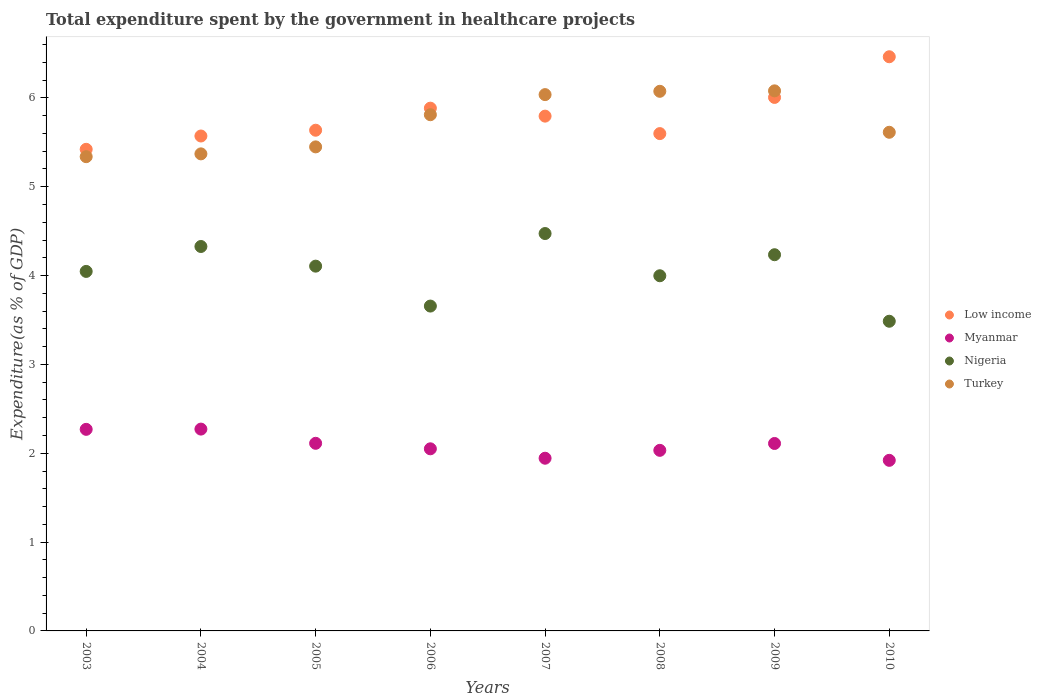Is the number of dotlines equal to the number of legend labels?
Offer a terse response. Yes. What is the total expenditure spent by the government in healthcare projects in Low income in 2006?
Give a very brief answer. 5.88. Across all years, what is the maximum total expenditure spent by the government in healthcare projects in Myanmar?
Give a very brief answer. 2.27. Across all years, what is the minimum total expenditure spent by the government in healthcare projects in Myanmar?
Keep it short and to the point. 1.92. What is the total total expenditure spent by the government in healthcare projects in Low income in the graph?
Your response must be concise. 46.38. What is the difference between the total expenditure spent by the government in healthcare projects in Nigeria in 2004 and that in 2008?
Offer a terse response. 0.33. What is the difference between the total expenditure spent by the government in healthcare projects in Turkey in 2004 and the total expenditure spent by the government in healthcare projects in Myanmar in 2008?
Your response must be concise. 3.34. What is the average total expenditure spent by the government in healthcare projects in Nigeria per year?
Provide a short and direct response. 4.04. In the year 2005, what is the difference between the total expenditure spent by the government in healthcare projects in Low income and total expenditure spent by the government in healthcare projects in Turkey?
Give a very brief answer. 0.19. What is the ratio of the total expenditure spent by the government in healthcare projects in Myanmar in 2004 to that in 2006?
Provide a short and direct response. 1.11. What is the difference between the highest and the second highest total expenditure spent by the government in healthcare projects in Nigeria?
Provide a succinct answer. 0.15. What is the difference between the highest and the lowest total expenditure spent by the government in healthcare projects in Turkey?
Provide a succinct answer. 0.74. In how many years, is the total expenditure spent by the government in healthcare projects in Turkey greater than the average total expenditure spent by the government in healthcare projects in Turkey taken over all years?
Keep it short and to the point. 4. Is it the case that in every year, the sum of the total expenditure spent by the government in healthcare projects in Turkey and total expenditure spent by the government in healthcare projects in Low income  is greater than the total expenditure spent by the government in healthcare projects in Nigeria?
Keep it short and to the point. Yes. Is the total expenditure spent by the government in healthcare projects in Turkey strictly greater than the total expenditure spent by the government in healthcare projects in Myanmar over the years?
Your answer should be compact. Yes. How many dotlines are there?
Provide a short and direct response. 4. What is the difference between two consecutive major ticks on the Y-axis?
Your response must be concise. 1. Does the graph contain any zero values?
Make the answer very short. No. Does the graph contain grids?
Ensure brevity in your answer.  No. How many legend labels are there?
Provide a succinct answer. 4. What is the title of the graph?
Keep it short and to the point. Total expenditure spent by the government in healthcare projects. Does "Kosovo" appear as one of the legend labels in the graph?
Ensure brevity in your answer.  No. What is the label or title of the X-axis?
Your response must be concise. Years. What is the label or title of the Y-axis?
Keep it short and to the point. Expenditure(as % of GDP). What is the Expenditure(as % of GDP) in Low income in 2003?
Your answer should be compact. 5.42. What is the Expenditure(as % of GDP) in Myanmar in 2003?
Make the answer very short. 2.27. What is the Expenditure(as % of GDP) of Nigeria in 2003?
Your response must be concise. 4.05. What is the Expenditure(as % of GDP) of Turkey in 2003?
Your answer should be very brief. 5.34. What is the Expenditure(as % of GDP) of Low income in 2004?
Your answer should be very brief. 5.57. What is the Expenditure(as % of GDP) in Myanmar in 2004?
Provide a succinct answer. 2.27. What is the Expenditure(as % of GDP) of Nigeria in 2004?
Offer a very short reply. 4.33. What is the Expenditure(as % of GDP) of Turkey in 2004?
Provide a short and direct response. 5.37. What is the Expenditure(as % of GDP) in Low income in 2005?
Give a very brief answer. 5.64. What is the Expenditure(as % of GDP) in Myanmar in 2005?
Your response must be concise. 2.11. What is the Expenditure(as % of GDP) of Nigeria in 2005?
Your answer should be very brief. 4.11. What is the Expenditure(as % of GDP) of Turkey in 2005?
Offer a very short reply. 5.45. What is the Expenditure(as % of GDP) in Low income in 2006?
Your answer should be very brief. 5.88. What is the Expenditure(as % of GDP) of Myanmar in 2006?
Provide a short and direct response. 2.05. What is the Expenditure(as % of GDP) of Nigeria in 2006?
Keep it short and to the point. 3.66. What is the Expenditure(as % of GDP) of Turkey in 2006?
Offer a terse response. 5.81. What is the Expenditure(as % of GDP) of Low income in 2007?
Give a very brief answer. 5.8. What is the Expenditure(as % of GDP) of Myanmar in 2007?
Provide a succinct answer. 1.94. What is the Expenditure(as % of GDP) of Nigeria in 2007?
Your answer should be compact. 4.47. What is the Expenditure(as % of GDP) of Turkey in 2007?
Offer a terse response. 6.04. What is the Expenditure(as % of GDP) of Low income in 2008?
Your answer should be compact. 5.6. What is the Expenditure(as % of GDP) of Myanmar in 2008?
Your response must be concise. 2.03. What is the Expenditure(as % of GDP) in Nigeria in 2008?
Make the answer very short. 4. What is the Expenditure(as % of GDP) of Turkey in 2008?
Make the answer very short. 6.07. What is the Expenditure(as % of GDP) in Low income in 2009?
Provide a short and direct response. 6.01. What is the Expenditure(as % of GDP) in Myanmar in 2009?
Give a very brief answer. 2.11. What is the Expenditure(as % of GDP) in Nigeria in 2009?
Provide a short and direct response. 4.23. What is the Expenditure(as % of GDP) of Turkey in 2009?
Offer a terse response. 6.08. What is the Expenditure(as % of GDP) of Low income in 2010?
Keep it short and to the point. 6.46. What is the Expenditure(as % of GDP) in Myanmar in 2010?
Your response must be concise. 1.92. What is the Expenditure(as % of GDP) in Nigeria in 2010?
Make the answer very short. 3.49. What is the Expenditure(as % of GDP) in Turkey in 2010?
Ensure brevity in your answer.  5.61. Across all years, what is the maximum Expenditure(as % of GDP) in Low income?
Give a very brief answer. 6.46. Across all years, what is the maximum Expenditure(as % of GDP) of Myanmar?
Offer a terse response. 2.27. Across all years, what is the maximum Expenditure(as % of GDP) in Nigeria?
Your answer should be compact. 4.47. Across all years, what is the maximum Expenditure(as % of GDP) of Turkey?
Your answer should be very brief. 6.08. Across all years, what is the minimum Expenditure(as % of GDP) of Low income?
Provide a short and direct response. 5.42. Across all years, what is the minimum Expenditure(as % of GDP) of Myanmar?
Keep it short and to the point. 1.92. Across all years, what is the minimum Expenditure(as % of GDP) of Nigeria?
Your answer should be very brief. 3.49. Across all years, what is the minimum Expenditure(as % of GDP) of Turkey?
Offer a very short reply. 5.34. What is the total Expenditure(as % of GDP) in Low income in the graph?
Make the answer very short. 46.38. What is the total Expenditure(as % of GDP) of Myanmar in the graph?
Ensure brevity in your answer.  16.71. What is the total Expenditure(as % of GDP) in Nigeria in the graph?
Your response must be concise. 32.33. What is the total Expenditure(as % of GDP) in Turkey in the graph?
Provide a succinct answer. 45.77. What is the difference between the Expenditure(as % of GDP) of Low income in 2003 and that in 2004?
Offer a very short reply. -0.15. What is the difference between the Expenditure(as % of GDP) of Myanmar in 2003 and that in 2004?
Give a very brief answer. -0. What is the difference between the Expenditure(as % of GDP) of Nigeria in 2003 and that in 2004?
Give a very brief answer. -0.28. What is the difference between the Expenditure(as % of GDP) in Turkey in 2003 and that in 2004?
Keep it short and to the point. -0.03. What is the difference between the Expenditure(as % of GDP) in Low income in 2003 and that in 2005?
Offer a very short reply. -0.21. What is the difference between the Expenditure(as % of GDP) of Myanmar in 2003 and that in 2005?
Provide a short and direct response. 0.16. What is the difference between the Expenditure(as % of GDP) in Nigeria in 2003 and that in 2005?
Your answer should be very brief. -0.06. What is the difference between the Expenditure(as % of GDP) of Turkey in 2003 and that in 2005?
Keep it short and to the point. -0.11. What is the difference between the Expenditure(as % of GDP) of Low income in 2003 and that in 2006?
Keep it short and to the point. -0.46. What is the difference between the Expenditure(as % of GDP) of Myanmar in 2003 and that in 2006?
Give a very brief answer. 0.22. What is the difference between the Expenditure(as % of GDP) of Nigeria in 2003 and that in 2006?
Your answer should be very brief. 0.39. What is the difference between the Expenditure(as % of GDP) of Turkey in 2003 and that in 2006?
Make the answer very short. -0.47. What is the difference between the Expenditure(as % of GDP) of Low income in 2003 and that in 2007?
Your answer should be very brief. -0.37. What is the difference between the Expenditure(as % of GDP) of Myanmar in 2003 and that in 2007?
Your answer should be very brief. 0.33. What is the difference between the Expenditure(as % of GDP) in Nigeria in 2003 and that in 2007?
Give a very brief answer. -0.43. What is the difference between the Expenditure(as % of GDP) of Turkey in 2003 and that in 2007?
Your answer should be compact. -0.7. What is the difference between the Expenditure(as % of GDP) in Low income in 2003 and that in 2008?
Ensure brevity in your answer.  -0.18. What is the difference between the Expenditure(as % of GDP) in Myanmar in 2003 and that in 2008?
Your answer should be very brief. 0.24. What is the difference between the Expenditure(as % of GDP) in Nigeria in 2003 and that in 2008?
Offer a very short reply. 0.05. What is the difference between the Expenditure(as % of GDP) of Turkey in 2003 and that in 2008?
Your response must be concise. -0.74. What is the difference between the Expenditure(as % of GDP) in Low income in 2003 and that in 2009?
Your response must be concise. -0.58. What is the difference between the Expenditure(as % of GDP) in Myanmar in 2003 and that in 2009?
Ensure brevity in your answer.  0.16. What is the difference between the Expenditure(as % of GDP) of Nigeria in 2003 and that in 2009?
Give a very brief answer. -0.19. What is the difference between the Expenditure(as % of GDP) of Turkey in 2003 and that in 2009?
Ensure brevity in your answer.  -0.74. What is the difference between the Expenditure(as % of GDP) in Low income in 2003 and that in 2010?
Give a very brief answer. -1.04. What is the difference between the Expenditure(as % of GDP) of Myanmar in 2003 and that in 2010?
Your answer should be compact. 0.35. What is the difference between the Expenditure(as % of GDP) of Nigeria in 2003 and that in 2010?
Offer a very short reply. 0.56. What is the difference between the Expenditure(as % of GDP) of Turkey in 2003 and that in 2010?
Your response must be concise. -0.27. What is the difference between the Expenditure(as % of GDP) in Low income in 2004 and that in 2005?
Offer a terse response. -0.07. What is the difference between the Expenditure(as % of GDP) of Myanmar in 2004 and that in 2005?
Ensure brevity in your answer.  0.16. What is the difference between the Expenditure(as % of GDP) in Nigeria in 2004 and that in 2005?
Keep it short and to the point. 0.22. What is the difference between the Expenditure(as % of GDP) of Turkey in 2004 and that in 2005?
Your response must be concise. -0.08. What is the difference between the Expenditure(as % of GDP) in Low income in 2004 and that in 2006?
Offer a terse response. -0.31. What is the difference between the Expenditure(as % of GDP) of Myanmar in 2004 and that in 2006?
Your answer should be very brief. 0.22. What is the difference between the Expenditure(as % of GDP) in Nigeria in 2004 and that in 2006?
Your response must be concise. 0.67. What is the difference between the Expenditure(as % of GDP) in Turkey in 2004 and that in 2006?
Keep it short and to the point. -0.44. What is the difference between the Expenditure(as % of GDP) of Low income in 2004 and that in 2007?
Your response must be concise. -0.22. What is the difference between the Expenditure(as % of GDP) in Myanmar in 2004 and that in 2007?
Ensure brevity in your answer.  0.33. What is the difference between the Expenditure(as % of GDP) of Nigeria in 2004 and that in 2007?
Keep it short and to the point. -0.15. What is the difference between the Expenditure(as % of GDP) in Turkey in 2004 and that in 2007?
Offer a very short reply. -0.67. What is the difference between the Expenditure(as % of GDP) of Low income in 2004 and that in 2008?
Provide a short and direct response. -0.03. What is the difference between the Expenditure(as % of GDP) of Myanmar in 2004 and that in 2008?
Your answer should be very brief. 0.24. What is the difference between the Expenditure(as % of GDP) in Nigeria in 2004 and that in 2008?
Your answer should be very brief. 0.33. What is the difference between the Expenditure(as % of GDP) of Turkey in 2004 and that in 2008?
Your answer should be compact. -0.7. What is the difference between the Expenditure(as % of GDP) in Low income in 2004 and that in 2009?
Provide a short and direct response. -0.43. What is the difference between the Expenditure(as % of GDP) of Myanmar in 2004 and that in 2009?
Offer a terse response. 0.16. What is the difference between the Expenditure(as % of GDP) of Nigeria in 2004 and that in 2009?
Your response must be concise. 0.09. What is the difference between the Expenditure(as % of GDP) in Turkey in 2004 and that in 2009?
Keep it short and to the point. -0.71. What is the difference between the Expenditure(as % of GDP) in Low income in 2004 and that in 2010?
Provide a short and direct response. -0.89. What is the difference between the Expenditure(as % of GDP) of Myanmar in 2004 and that in 2010?
Your answer should be compact. 0.35. What is the difference between the Expenditure(as % of GDP) of Nigeria in 2004 and that in 2010?
Your answer should be compact. 0.84. What is the difference between the Expenditure(as % of GDP) of Turkey in 2004 and that in 2010?
Offer a very short reply. -0.24. What is the difference between the Expenditure(as % of GDP) in Low income in 2005 and that in 2006?
Offer a very short reply. -0.25. What is the difference between the Expenditure(as % of GDP) of Myanmar in 2005 and that in 2006?
Your answer should be compact. 0.06. What is the difference between the Expenditure(as % of GDP) of Nigeria in 2005 and that in 2006?
Provide a succinct answer. 0.45. What is the difference between the Expenditure(as % of GDP) in Turkey in 2005 and that in 2006?
Give a very brief answer. -0.36. What is the difference between the Expenditure(as % of GDP) in Low income in 2005 and that in 2007?
Provide a short and direct response. -0.16. What is the difference between the Expenditure(as % of GDP) of Myanmar in 2005 and that in 2007?
Make the answer very short. 0.17. What is the difference between the Expenditure(as % of GDP) in Nigeria in 2005 and that in 2007?
Your answer should be compact. -0.37. What is the difference between the Expenditure(as % of GDP) in Turkey in 2005 and that in 2007?
Give a very brief answer. -0.59. What is the difference between the Expenditure(as % of GDP) in Low income in 2005 and that in 2008?
Make the answer very short. 0.04. What is the difference between the Expenditure(as % of GDP) of Myanmar in 2005 and that in 2008?
Your response must be concise. 0.08. What is the difference between the Expenditure(as % of GDP) in Nigeria in 2005 and that in 2008?
Ensure brevity in your answer.  0.11. What is the difference between the Expenditure(as % of GDP) in Turkey in 2005 and that in 2008?
Offer a very short reply. -0.63. What is the difference between the Expenditure(as % of GDP) in Low income in 2005 and that in 2009?
Your answer should be compact. -0.37. What is the difference between the Expenditure(as % of GDP) in Myanmar in 2005 and that in 2009?
Your answer should be compact. 0. What is the difference between the Expenditure(as % of GDP) of Nigeria in 2005 and that in 2009?
Ensure brevity in your answer.  -0.13. What is the difference between the Expenditure(as % of GDP) of Turkey in 2005 and that in 2009?
Ensure brevity in your answer.  -0.63. What is the difference between the Expenditure(as % of GDP) in Low income in 2005 and that in 2010?
Your answer should be compact. -0.83. What is the difference between the Expenditure(as % of GDP) in Myanmar in 2005 and that in 2010?
Give a very brief answer. 0.19. What is the difference between the Expenditure(as % of GDP) of Nigeria in 2005 and that in 2010?
Provide a short and direct response. 0.62. What is the difference between the Expenditure(as % of GDP) of Turkey in 2005 and that in 2010?
Give a very brief answer. -0.16. What is the difference between the Expenditure(as % of GDP) in Low income in 2006 and that in 2007?
Ensure brevity in your answer.  0.09. What is the difference between the Expenditure(as % of GDP) of Myanmar in 2006 and that in 2007?
Keep it short and to the point. 0.11. What is the difference between the Expenditure(as % of GDP) in Nigeria in 2006 and that in 2007?
Offer a terse response. -0.82. What is the difference between the Expenditure(as % of GDP) of Turkey in 2006 and that in 2007?
Make the answer very short. -0.23. What is the difference between the Expenditure(as % of GDP) of Low income in 2006 and that in 2008?
Give a very brief answer. 0.29. What is the difference between the Expenditure(as % of GDP) in Myanmar in 2006 and that in 2008?
Offer a terse response. 0.02. What is the difference between the Expenditure(as % of GDP) in Nigeria in 2006 and that in 2008?
Offer a very short reply. -0.34. What is the difference between the Expenditure(as % of GDP) in Turkey in 2006 and that in 2008?
Provide a succinct answer. -0.26. What is the difference between the Expenditure(as % of GDP) in Low income in 2006 and that in 2009?
Your answer should be very brief. -0.12. What is the difference between the Expenditure(as % of GDP) of Myanmar in 2006 and that in 2009?
Give a very brief answer. -0.06. What is the difference between the Expenditure(as % of GDP) of Nigeria in 2006 and that in 2009?
Keep it short and to the point. -0.58. What is the difference between the Expenditure(as % of GDP) of Turkey in 2006 and that in 2009?
Offer a very short reply. -0.27. What is the difference between the Expenditure(as % of GDP) of Low income in 2006 and that in 2010?
Give a very brief answer. -0.58. What is the difference between the Expenditure(as % of GDP) of Myanmar in 2006 and that in 2010?
Ensure brevity in your answer.  0.13. What is the difference between the Expenditure(as % of GDP) in Nigeria in 2006 and that in 2010?
Your answer should be compact. 0.17. What is the difference between the Expenditure(as % of GDP) in Turkey in 2006 and that in 2010?
Give a very brief answer. 0.2. What is the difference between the Expenditure(as % of GDP) in Low income in 2007 and that in 2008?
Your response must be concise. 0.2. What is the difference between the Expenditure(as % of GDP) in Myanmar in 2007 and that in 2008?
Your answer should be very brief. -0.09. What is the difference between the Expenditure(as % of GDP) in Nigeria in 2007 and that in 2008?
Your answer should be compact. 0.48. What is the difference between the Expenditure(as % of GDP) in Turkey in 2007 and that in 2008?
Keep it short and to the point. -0.04. What is the difference between the Expenditure(as % of GDP) in Low income in 2007 and that in 2009?
Give a very brief answer. -0.21. What is the difference between the Expenditure(as % of GDP) of Myanmar in 2007 and that in 2009?
Offer a very short reply. -0.17. What is the difference between the Expenditure(as % of GDP) of Nigeria in 2007 and that in 2009?
Your response must be concise. 0.24. What is the difference between the Expenditure(as % of GDP) of Turkey in 2007 and that in 2009?
Keep it short and to the point. -0.04. What is the difference between the Expenditure(as % of GDP) of Low income in 2007 and that in 2010?
Provide a succinct answer. -0.67. What is the difference between the Expenditure(as % of GDP) in Myanmar in 2007 and that in 2010?
Make the answer very short. 0.02. What is the difference between the Expenditure(as % of GDP) of Nigeria in 2007 and that in 2010?
Give a very brief answer. 0.99. What is the difference between the Expenditure(as % of GDP) of Turkey in 2007 and that in 2010?
Your answer should be compact. 0.42. What is the difference between the Expenditure(as % of GDP) of Low income in 2008 and that in 2009?
Make the answer very short. -0.41. What is the difference between the Expenditure(as % of GDP) in Myanmar in 2008 and that in 2009?
Provide a short and direct response. -0.08. What is the difference between the Expenditure(as % of GDP) in Nigeria in 2008 and that in 2009?
Make the answer very short. -0.24. What is the difference between the Expenditure(as % of GDP) in Turkey in 2008 and that in 2009?
Make the answer very short. -0.01. What is the difference between the Expenditure(as % of GDP) of Low income in 2008 and that in 2010?
Make the answer very short. -0.87. What is the difference between the Expenditure(as % of GDP) of Myanmar in 2008 and that in 2010?
Your answer should be very brief. 0.11. What is the difference between the Expenditure(as % of GDP) of Nigeria in 2008 and that in 2010?
Give a very brief answer. 0.51. What is the difference between the Expenditure(as % of GDP) in Turkey in 2008 and that in 2010?
Your answer should be compact. 0.46. What is the difference between the Expenditure(as % of GDP) in Low income in 2009 and that in 2010?
Provide a short and direct response. -0.46. What is the difference between the Expenditure(as % of GDP) of Myanmar in 2009 and that in 2010?
Your response must be concise. 0.19. What is the difference between the Expenditure(as % of GDP) in Nigeria in 2009 and that in 2010?
Provide a succinct answer. 0.75. What is the difference between the Expenditure(as % of GDP) of Turkey in 2009 and that in 2010?
Provide a succinct answer. 0.47. What is the difference between the Expenditure(as % of GDP) of Low income in 2003 and the Expenditure(as % of GDP) of Myanmar in 2004?
Your response must be concise. 3.15. What is the difference between the Expenditure(as % of GDP) in Low income in 2003 and the Expenditure(as % of GDP) in Nigeria in 2004?
Provide a succinct answer. 1.09. What is the difference between the Expenditure(as % of GDP) of Low income in 2003 and the Expenditure(as % of GDP) of Turkey in 2004?
Your answer should be very brief. 0.05. What is the difference between the Expenditure(as % of GDP) in Myanmar in 2003 and the Expenditure(as % of GDP) in Nigeria in 2004?
Provide a succinct answer. -2.06. What is the difference between the Expenditure(as % of GDP) in Myanmar in 2003 and the Expenditure(as % of GDP) in Turkey in 2004?
Make the answer very short. -3.1. What is the difference between the Expenditure(as % of GDP) of Nigeria in 2003 and the Expenditure(as % of GDP) of Turkey in 2004?
Your answer should be compact. -1.32. What is the difference between the Expenditure(as % of GDP) in Low income in 2003 and the Expenditure(as % of GDP) in Myanmar in 2005?
Offer a terse response. 3.31. What is the difference between the Expenditure(as % of GDP) in Low income in 2003 and the Expenditure(as % of GDP) in Nigeria in 2005?
Provide a succinct answer. 1.32. What is the difference between the Expenditure(as % of GDP) of Low income in 2003 and the Expenditure(as % of GDP) of Turkey in 2005?
Ensure brevity in your answer.  -0.03. What is the difference between the Expenditure(as % of GDP) of Myanmar in 2003 and the Expenditure(as % of GDP) of Nigeria in 2005?
Provide a short and direct response. -1.84. What is the difference between the Expenditure(as % of GDP) in Myanmar in 2003 and the Expenditure(as % of GDP) in Turkey in 2005?
Give a very brief answer. -3.18. What is the difference between the Expenditure(as % of GDP) of Nigeria in 2003 and the Expenditure(as % of GDP) of Turkey in 2005?
Provide a short and direct response. -1.4. What is the difference between the Expenditure(as % of GDP) in Low income in 2003 and the Expenditure(as % of GDP) in Myanmar in 2006?
Your answer should be very brief. 3.37. What is the difference between the Expenditure(as % of GDP) of Low income in 2003 and the Expenditure(as % of GDP) of Nigeria in 2006?
Make the answer very short. 1.76. What is the difference between the Expenditure(as % of GDP) of Low income in 2003 and the Expenditure(as % of GDP) of Turkey in 2006?
Your answer should be compact. -0.39. What is the difference between the Expenditure(as % of GDP) in Myanmar in 2003 and the Expenditure(as % of GDP) in Nigeria in 2006?
Your answer should be very brief. -1.39. What is the difference between the Expenditure(as % of GDP) in Myanmar in 2003 and the Expenditure(as % of GDP) in Turkey in 2006?
Your response must be concise. -3.54. What is the difference between the Expenditure(as % of GDP) of Nigeria in 2003 and the Expenditure(as % of GDP) of Turkey in 2006?
Offer a terse response. -1.76. What is the difference between the Expenditure(as % of GDP) of Low income in 2003 and the Expenditure(as % of GDP) of Myanmar in 2007?
Offer a very short reply. 3.48. What is the difference between the Expenditure(as % of GDP) of Low income in 2003 and the Expenditure(as % of GDP) of Nigeria in 2007?
Offer a very short reply. 0.95. What is the difference between the Expenditure(as % of GDP) in Low income in 2003 and the Expenditure(as % of GDP) in Turkey in 2007?
Give a very brief answer. -0.62. What is the difference between the Expenditure(as % of GDP) of Myanmar in 2003 and the Expenditure(as % of GDP) of Nigeria in 2007?
Offer a terse response. -2.2. What is the difference between the Expenditure(as % of GDP) in Myanmar in 2003 and the Expenditure(as % of GDP) in Turkey in 2007?
Your answer should be very brief. -3.77. What is the difference between the Expenditure(as % of GDP) in Nigeria in 2003 and the Expenditure(as % of GDP) in Turkey in 2007?
Provide a short and direct response. -1.99. What is the difference between the Expenditure(as % of GDP) in Low income in 2003 and the Expenditure(as % of GDP) in Myanmar in 2008?
Your answer should be very brief. 3.39. What is the difference between the Expenditure(as % of GDP) of Low income in 2003 and the Expenditure(as % of GDP) of Nigeria in 2008?
Ensure brevity in your answer.  1.42. What is the difference between the Expenditure(as % of GDP) of Low income in 2003 and the Expenditure(as % of GDP) of Turkey in 2008?
Offer a very short reply. -0.65. What is the difference between the Expenditure(as % of GDP) of Myanmar in 2003 and the Expenditure(as % of GDP) of Nigeria in 2008?
Your response must be concise. -1.73. What is the difference between the Expenditure(as % of GDP) in Myanmar in 2003 and the Expenditure(as % of GDP) in Turkey in 2008?
Your response must be concise. -3.81. What is the difference between the Expenditure(as % of GDP) of Nigeria in 2003 and the Expenditure(as % of GDP) of Turkey in 2008?
Provide a succinct answer. -2.03. What is the difference between the Expenditure(as % of GDP) in Low income in 2003 and the Expenditure(as % of GDP) in Myanmar in 2009?
Keep it short and to the point. 3.31. What is the difference between the Expenditure(as % of GDP) in Low income in 2003 and the Expenditure(as % of GDP) in Nigeria in 2009?
Your response must be concise. 1.19. What is the difference between the Expenditure(as % of GDP) of Low income in 2003 and the Expenditure(as % of GDP) of Turkey in 2009?
Ensure brevity in your answer.  -0.66. What is the difference between the Expenditure(as % of GDP) of Myanmar in 2003 and the Expenditure(as % of GDP) of Nigeria in 2009?
Offer a terse response. -1.97. What is the difference between the Expenditure(as % of GDP) in Myanmar in 2003 and the Expenditure(as % of GDP) in Turkey in 2009?
Make the answer very short. -3.81. What is the difference between the Expenditure(as % of GDP) of Nigeria in 2003 and the Expenditure(as % of GDP) of Turkey in 2009?
Offer a very short reply. -2.03. What is the difference between the Expenditure(as % of GDP) of Low income in 2003 and the Expenditure(as % of GDP) of Myanmar in 2010?
Provide a short and direct response. 3.5. What is the difference between the Expenditure(as % of GDP) in Low income in 2003 and the Expenditure(as % of GDP) in Nigeria in 2010?
Give a very brief answer. 1.94. What is the difference between the Expenditure(as % of GDP) in Low income in 2003 and the Expenditure(as % of GDP) in Turkey in 2010?
Your answer should be compact. -0.19. What is the difference between the Expenditure(as % of GDP) in Myanmar in 2003 and the Expenditure(as % of GDP) in Nigeria in 2010?
Make the answer very short. -1.22. What is the difference between the Expenditure(as % of GDP) of Myanmar in 2003 and the Expenditure(as % of GDP) of Turkey in 2010?
Make the answer very short. -3.34. What is the difference between the Expenditure(as % of GDP) of Nigeria in 2003 and the Expenditure(as % of GDP) of Turkey in 2010?
Your response must be concise. -1.57. What is the difference between the Expenditure(as % of GDP) in Low income in 2004 and the Expenditure(as % of GDP) in Myanmar in 2005?
Give a very brief answer. 3.46. What is the difference between the Expenditure(as % of GDP) in Low income in 2004 and the Expenditure(as % of GDP) in Nigeria in 2005?
Make the answer very short. 1.47. What is the difference between the Expenditure(as % of GDP) in Low income in 2004 and the Expenditure(as % of GDP) in Turkey in 2005?
Ensure brevity in your answer.  0.12. What is the difference between the Expenditure(as % of GDP) of Myanmar in 2004 and the Expenditure(as % of GDP) of Nigeria in 2005?
Your answer should be very brief. -1.83. What is the difference between the Expenditure(as % of GDP) in Myanmar in 2004 and the Expenditure(as % of GDP) in Turkey in 2005?
Keep it short and to the point. -3.18. What is the difference between the Expenditure(as % of GDP) of Nigeria in 2004 and the Expenditure(as % of GDP) of Turkey in 2005?
Your response must be concise. -1.12. What is the difference between the Expenditure(as % of GDP) in Low income in 2004 and the Expenditure(as % of GDP) in Myanmar in 2006?
Provide a short and direct response. 3.52. What is the difference between the Expenditure(as % of GDP) of Low income in 2004 and the Expenditure(as % of GDP) of Nigeria in 2006?
Your answer should be compact. 1.91. What is the difference between the Expenditure(as % of GDP) in Low income in 2004 and the Expenditure(as % of GDP) in Turkey in 2006?
Offer a terse response. -0.24. What is the difference between the Expenditure(as % of GDP) in Myanmar in 2004 and the Expenditure(as % of GDP) in Nigeria in 2006?
Offer a terse response. -1.38. What is the difference between the Expenditure(as % of GDP) in Myanmar in 2004 and the Expenditure(as % of GDP) in Turkey in 2006?
Your answer should be very brief. -3.54. What is the difference between the Expenditure(as % of GDP) in Nigeria in 2004 and the Expenditure(as % of GDP) in Turkey in 2006?
Your response must be concise. -1.48. What is the difference between the Expenditure(as % of GDP) in Low income in 2004 and the Expenditure(as % of GDP) in Myanmar in 2007?
Your answer should be compact. 3.63. What is the difference between the Expenditure(as % of GDP) in Low income in 2004 and the Expenditure(as % of GDP) in Nigeria in 2007?
Make the answer very short. 1.1. What is the difference between the Expenditure(as % of GDP) in Low income in 2004 and the Expenditure(as % of GDP) in Turkey in 2007?
Provide a short and direct response. -0.47. What is the difference between the Expenditure(as % of GDP) in Myanmar in 2004 and the Expenditure(as % of GDP) in Nigeria in 2007?
Make the answer very short. -2.2. What is the difference between the Expenditure(as % of GDP) of Myanmar in 2004 and the Expenditure(as % of GDP) of Turkey in 2007?
Offer a terse response. -3.77. What is the difference between the Expenditure(as % of GDP) in Nigeria in 2004 and the Expenditure(as % of GDP) in Turkey in 2007?
Provide a succinct answer. -1.71. What is the difference between the Expenditure(as % of GDP) of Low income in 2004 and the Expenditure(as % of GDP) of Myanmar in 2008?
Provide a succinct answer. 3.54. What is the difference between the Expenditure(as % of GDP) of Low income in 2004 and the Expenditure(as % of GDP) of Nigeria in 2008?
Keep it short and to the point. 1.57. What is the difference between the Expenditure(as % of GDP) of Low income in 2004 and the Expenditure(as % of GDP) of Turkey in 2008?
Your response must be concise. -0.5. What is the difference between the Expenditure(as % of GDP) in Myanmar in 2004 and the Expenditure(as % of GDP) in Nigeria in 2008?
Make the answer very short. -1.73. What is the difference between the Expenditure(as % of GDP) in Myanmar in 2004 and the Expenditure(as % of GDP) in Turkey in 2008?
Ensure brevity in your answer.  -3.8. What is the difference between the Expenditure(as % of GDP) in Nigeria in 2004 and the Expenditure(as % of GDP) in Turkey in 2008?
Your answer should be compact. -1.75. What is the difference between the Expenditure(as % of GDP) of Low income in 2004 and the Expenditure(as % of GDP) of Myanmar in 2009?
Make the answer very short. 3.46. What is the difference between the Expenditure(as % of GDP) in Low income in 2004 and the Expenditure(as % of GDP) in Nigeria in 2009?
Your answer should be very brief. 1.34. What is the difference between the Expenditure(as % of GDP) in Low income in 2004 and the Expenditure(as % of GDP) in Turkey in 2009?
Keep it short and to the point. -0.51. What is the difference between the Expenditure(as % of GDP) of Myanmar in 2004 and the Expenditure(as % of GDP) of Nigeria in 2009?
Provide a short and direct response. -1.96. What is the difference between the Expenditure(as % of GDP) in Myanmar in 2004 and the Expenditure(as % of GDP) in Turkey in 2009?
Provide a succinct answer. -3.81. What is the difference between the Expenditure(as % of GDP) of Nigeria in 2004 and the Expenditure(as % of GDP) of Turkey in 2009?
Offer a very short reply. -1.75. What is the difference between the Expenditure(as % of GDP) of Low income in 2004 and the Expenditure(as % of GDP) of Myanmar in 2010?
Provide a succinct answer. 3.65. What is the difference between the Expenditure(as % of GDP) in Low income in 2004 and the Expenditure(as % of GDP) in Nigeria in 2010?
Offer a terse response. 2.09. What is the difference between the Expenditure(as % of GDP) of Low income in 2004 and the Expenditure(as % of GDP) of Turkey in 2010?
Ensure brevity in your answer.  -0.04. What is the difference between the Expenditure(as % of GDP) of Myanmar in 2004 and the Expenditure(as % of GDP) of Nigeria in 2010?
Your answer should be compact. -1.21. What is the difference between the Expenditure(as % of GDP) in Myanmar in 2004 and the Expenditure(as % of GDP) in Turkey in 2010?
Provide a succinct answer. -3.34. What is the difference between the Expenditure(as % of GDP) of Nigeria in 2004 and the Expenditure(as % of GDP) of Turkey in 2010?
Your answer should be very brief. -1.29. What is the difference between the Expenditure(as % of GDP) in Low income in 2005 and the Expenditure(as % of GDP) in Myanmar in 2006?
Your response must be concise. 3.59. What is the difference between the Expenditure(as % of GDP) of Low income in 2005 and the Expenditure(as % of GDP) of Nigeria in 2006?
Ensure brevity in your answer.  1.98. What is the difference between the Expenditure(as % of GDP) of Low income in 2005 and the Expenditure(as % of GDP) of Turkey in 2006?
Offer a very short reply. -0.17. What is the difference between the Expenditure(as % of GDP) of Myanmar in 2005 and the Expenditure(as % of GDP) of Nigeria in 2006?
Your answer should be compact. -1.54. What is the difference between the Expenditure(as % of GDP) of Myanmar in 2005 and the Expenditure(as % of GDP) of Turkey in 2006?
Provide a short and direct response. -3.7. What is the difference between the Expenditure(as % of GDP) of Nigeria in 2005 and the Expenditure(as % of GDP) of Turkey in 2006?
Make the answer very short. -1.7. What is the difference between the Expenditure(as % of GDP) in Low income in 2005 and the Expenditure(as % of GDP) in Myanmar in 2007?
Your answer should be compact. 3.69. What is the difference between the Expenditure(as % of GDP) of Low income in 2005 and the Expenditure(as % of GDP) of Nigeria in 2007?
Ensure brevity in your answer.  1.16. What is the difference between the Expenditure(as % of GDP) of Low income in 2005 and the Expenditure(as % of GDP) of Turkey in 2007?
Ensure brevity in your answer.  -0.4. What is the difference between the Expenditure(as % of GDP) in Myanmar in 2005 and the Expenditure(as % of GDP) in Nigeria in 2007?
Provide a succinct answer. -2.36. What is the difference between the Expenditure(as % of GDP) in Myanmar in 2005 and the Expenditure(as % of GDP) in Turkey in 2007?
Your answer should be compact. -3.93. What is the difference between the Expenditure(as % of GDP) in Nigeria in 2005 and the Expenditure(as % of GDP) in Turkey in 2007?
Make the answer very short. -1.93. What is the difference between the Expenditure(as % of GDP) in Low income in 2005 and the Expenditure(as % of GDP) in Myanmar in 2008?
Your response must be concise. 3.6. What is the difference between the Expenditure(as % of GDP) of Low income in 2005 and the Expenditure(as % of GDP) of Nigeria in 2008?
Make the answer very short. 1.64. What is the difference between the Expenditure(as % of GDP) of Low income in 2005 and the Expenditure(as % of GDP) of Turkey in 2008?
Provide a short and direct response. -0.44. What is the difference between the Expenditure(as % of GDP) in Myanmar in 2005 and the Expenditure(as % of GDP) in Nigeria in 2008?
Your answer should be very brief. -1.89. What is the difference between the Expenditure(as % of GDP) in Myanmar in 2005 and the Expenditure(as % of GDP) in Turkey in 2008?
Provide a short and direct response. -3.96. What is the difference between the Expenditure(as % of GDP) of Nigeria in 2005 and the Expenditure(as % of GDP) of Turkey in 2008?
Offer a terse response. -1.97. What is the difference between the Expenditure(as % of GDP) in Low income in 2005 and the Expenditure(as % of GDP) in Myanmar in 2009?
Provide a succinct answer. 3.53. What is the difference between the Expenditure(as % of GDP) in Low income in 2005 and the Expenditure(as % of GDP) in Nigeria in 2009?
Provide a succinct answer. 1.4. What is the difference between the Expenditure(as % of GDP) of Low income in 2005 and the Expenditure(as % of GDP) of Turkey in 2009?
Offer a terse response. -0.44. What is the difference between the Expenditure(as % of GDP) in Myanmar in 2005 and the Expenditure(as % of GDP) in Nigeria in 2009?
Make the answer very short. -2.12. What is the difference between the Expenditure(as % of GDP) in Myanmar in 2005 and the Expenditure(as % of GDP) in Turkey in 2009?
Provide a succinct answer. -3.97. What is the difference between the Expenditure(as % of GDP) in Nigeria in 2005 and the Expenditure(as % of GDP) in Turkey in 2009?
Make the answer very short. -1.97. What is the difference between the Expenditure(as % of GDP) of Low income in 2005 and the Expenditure(as % of GDP) of Myanmar in 2010?
Provide a short and direct response. 3.72. What is the difference between the Expenditure(as % of GDP) in Low income in 2005 and the Expenditure(as % of GDP) in Nigeria in 2010?
Your answer should be very brief. 2.15. What is the difference between the Expenditure(as % of GDP) of Low income in 2005 and the Expenditure(as % of GDP) of Turkey in 2010?
Give a very brief answer. 0.02. What is the difference between the Expenditure(as % of GDP) of Myanmar in 2005 and the Expenditure(as % of GDP) of Nigeria in 2010?
Keep it short and to the point. -1.37. What is the difference between the Expenditure(as % of GDP) in Myanmar in 2005 and the Expenditure(as % of GDP) in Turkey in 2010?
Make the answer very short. -3.5. What is the difference between the Expenditure(as % of GDP) in Nigeria in 2005 and the Expenditure(as % of GDP) in Turkey in 2010?
Your answer should be compact. -1.51. What is the difference between the Expenditure(as % of GDP) of Low income in 2006 and the Expenditure(as % of GDP) of Myanmar in 2007?
Offer a terse response. 3.94. What is the difference between the Expenditure(as % of GDP) of Low income in 2006 and the Expenditure(as % of GDP) of Nigeria in 2007?
Give a very brief answer. 1.41. What is the difference between the Expenditure(as % of GDP) in Low income in 2006 and the Expenditure(as % of GDP) in Turkey in 2007?
Your answer should be very brief. -0.15. What is the difference between the Expenditure(as % of GDP) of Myanmar in 2006 and the Expenditure(as % of GDP) of Nigeria in 2007?
Offer a very short reply. -2.42. What is the difference between the Expenditure(as % of GDP) in Myanmar in 2006 and the Expenditure(as % of GDP) in Turkey in 2007?
Give a very brief answer. -3.99. What is the difference between the Expenditure(as % of GDP) in Nigeria in 2006 and the Expenditure(as % of GDP) in Turkey in 2007?
Your answer should be compact. -2.38. What is the difference between the Expenditure(as % of GDP) in Low income in 2006 and the Expenditure(as % of GDP) in Myanmar in 2008?
Your answer should be very brief. 3.85. What is the difference between the Expenditure(as % of GDP) in Low income in 2006 and the Expenditure(as % of GDP) in Nigeria in 2008?
Your answer should be very brief. 1.89. What is the difference between the Expenditure(as % of GDP) of Low income in 2006 and the Expenditure(as % of GDP) of Turkey in 2008?
Provide a succinct answer. -0.19. What is the difference between the Expenditure(as % of GDP) in Myanmar in 2006 and the Expenditure(as % of GDP) in Nigeria in 2008?
Keep it short and to the point. -1.95. What is the difference between the Expenditure(as % of GDP) of Myanmar in 2006 and the Expenditure(as % of GDP) of Turkey in 2008?
Provide a succinct answer. -4.02. What is the difference between the Expenditure(as % of GDP) of Nigeria in 2006 and the Expenditure(as % of GDP) of Turkey in 2008?
Offer a very short reply. -2.42. What is the difference between the Expenditure(as % of GDP) in Low income in 2006 and the Expenditure(as % of GDP) in Myanmar in 2009?
Make the answer very short. 3.77. What is the difference between the Expenditure(as % of GDP) in Low income in 2006 and the Expenditure(as % of GDP) in Nigeria in 2009?
Give a very brief answer. 1.65. What is the difference between the Expenditure(as % of GDP) of Low income in 2006 and the Expenditure(as % of GDP) of Turkey in 2009?
Provide a succinct answer. -0.19. What is the difference between the Expenditure(as % of GDP) of Myanmar in 2006 and the Expenditure(as % of GDP) of Nigeria in 2009?
Your response must be concise. -2.18. What is the difference between the Expenditure(as % of GDP) in Myanmar in 2006 and the Expenditure(as % of GDP) in Turkey in 2009?
Ensure brevity in your answer.  -4.03. What is the difference between the Expenditure(as % of GDP) in Nigeria in 2006 and the Expenditure(as % of GDP) in Turkey in 2009?
Provide a succinct answer. -2.42. What is the difference between the Expenditure(as % of GDP) of Low income in 2006 and the Expenditure(as % of GDP) of Myanmar in 2010?
Provide a short and direct response. 3.96. What is the difference between the Expenditure(as % of GDP) of Low income in 2006 and the Expenditure(as % of GDP) of Nigeria in 2010?
Ensure brevity in your answer.  2.4. What is the difference between the Expenditure(as % of GDP) in Low income in 2006 and the Expenditure(as % of GDP) in Turkey in 2010?
Make the answer very short. 0.27. What is the difference between the Expenditure(as % of GDP) in Myanmar in 2006 and the Expenditure(as % of GDP) in Nigeria in 2010?
Your answer should be very brief. -1.44. What is the difference between the Expenditure(as % of GDP) of Myanmar in 2006 and the Expenditure(as % of GDP) of Turkey in 2010?
Provide a short and direct response. -3.56. What is the difference between the Expenditure(as % of GDP) of Nigeria in 2006 and the Expenditure(as % of GDP) of Turkey in 2010?
Provide a succinct answer. -1.96. What is the difference between the Expenditure(as % of GDP) of Low income in 2007 and the Expenditure(as % of GDP) of Myanmar in 2008?
Provide a succinct answer. 3.76. What is the difference between the Expenditure(as % of GDP) of Low income in 2007 and the Expenditure(as % of GDP) of Nigeria in 2008?
Give a very brief answer. 1.8. What is the difference between the Expenditure(as % of GDP) in Low income in 2007 and the Expenditure(as % of GDP) in Turkey in 2008?
Your answer should be compact. -0.28. What is the difference between the Expenditure(as % of GDP) of Myanmar in 2007 and the Expenditure(as % of GDP) of Nigeria in 2008?
Provide a succinct answer. -2.05. What is the difference between the Expenditure(as % of GDP) of Myanmar in 2007 and the Expenditure(as % of GDP) of Turkey in 2008?
Provide a short and direct response. -4.13. What is the difference between the Expenditure(as % of GDP) in Nigeria in 2007 and the Expenditure(as % of GDP) in Turkey in 2008?
Ensure brevity in your answer.  -1.6. What is the difference between the Expenditure(as % of GDP) of Low income in 2007 and the Expenditure(as % of GDP) of Myanmar in 2009?
Ensure brevity in your answer.  3.69. What is the difference between the Expenditure(as % of GDP) in Low income in 2007 and the Expenditure(as % of GDP) in Nigeria in 2009?
Provide a short and direct response. 1.56. What is the difference between the Expenditure(as % of GDP) in Low income in 2007 and the Expenditure(as % of GDP) in Turkey in 2009?
Provide a succinct answer. -0.28. What is the difference between the Expenditure(as % of GDP) of Myanmar in 2007 and the Expenditure(as % of GDP) of Nigeria in 2009?
Your answer should be very brief. -2.29. What is the difference between the Expenditure(as % of GDP) of Myanmar in 2007 and the Expenditure(as % of GDP) of Turkey in 2009?
Offer a very short reply. -4.14. What is the difference between the Expenditure(as % of GDP) in Nigeria in 2007 and the Expenditure(as % of GDP) in Turkey in 2009?
Offer a very short reply. -1.61. What is the difference between the Expenditure(as % of GDP) in Low income in 2007 and the Expenditure(as % of GDP) in Myanmar in 2010?
Make the answer very short. 3.87. What is the difference between the Expenditure(as % of GDP) in Low income in 2007 and the Expenditure(as % of GDP) in Nigeria in 2010?
Your answer should be compact. 2.31. What is the difference between the Expenditure(as % of GDP) in Low income in 2007 and the Expenditure(as % of GDP) in Turkey in 2010?
Give a very brief answer. 0.18. What is the difference between the Expenditure(as % of GDP) in Myanmar in 2007 and the Expenditure(as % of GDP) in Nigeria in 2010?
Provide a succinct answer. -1.54. What is the difference between the Expenditure(as % of GDP) of Myanmar in 2007 and the Expenditure(as % of GDP) of Turkey in 2010?
Ensure brevity in your answer.  -3.67. What is the difference between the Expenditure(as % of GDP) of Nigeria in 2007 and the Expenditure(as % of GDP) of Turkey in 2010?
Offer a very short reply. -1.14. What is the difference between the Expenditure(as % of GDP) in Low income in 2008 and the Expenditure(as % of GDP) in Myanmar in 2009?
Your answer should be very brief. 3.49. What is the difference between the Expenditure(as % of GDP) of Low income in 2008 and the Expenditure(as % of GDP) of Nigeria in 2009?
Ensure brevity in your answer.  1.36. What is the difference between the Expenditure(as % of GDP) of Low income in 2008 and the Expenditure(as % of GDP) of Turkey in 2009?
Your answer should be very brief. -0.48. What is the difference between the Expenditure(as % of GDP) in Myanmar in 2008 and the Expenditure(as % of GDP) in Nigeria in 2009?
Give a very brief answer. -2.2. What is the difference between the Expenditure(as % of GDP) of Myanmar in 2008 and the Expenditure(as % of GDP) of Turkey in 2009?
Offer a very short reply. -4.05. What is the difference between the Expenditure(as % of GDP) in Nigeria in 2008 and the Expenditure(as % of GDP) in Turkey in 2009?
Your answer should be compact. -2.08. What is the difference between the Expenditure(as % of GDP) of Low income in 2008 and the Expenditure(as % of GDP) of Myanmar in 2010?
Give a very brief answer. 3.68. What is the difference between the Expenditure(as % of GDP) of Low income in 2008 and the Expenditure(as % of GDP) of Nigeria in 2010?
Your response must be concise. 2.11. What is the difference between the Expenditure(as % of GDP) of Low income in 2008 and the Expenditure(as % of GDP) of Turkey in 2010?
Ensure brevity in your answer.  -0.01. What is the difference between the Expenditure(as % of GDP) in Myanmar in 2008 and the Expenditure(as % of GDP) in Nigeria in 2010?
Your response must be concise. -1.45. What is the difference between the Expenditure(as % of GDP) of Myanmar in 2008 and the Expenditure(as % of GDP) of Turkey in 2010?
Give a very brief answer. -3.58. What is the difference between the Expenditure(as % of GDP) in Nigeria in 2008 and the Expenditure(as % of GDP) in Turkey in 2010?
Provide a succinct answer. -1.62. What is the difference between the Expenditure(as % of GDP) in Low income in 2009 and the Expenditure(as % of GDP) in Myanmar in 2010?
Offer a very short reply. 4.09. What is the difference between the Expenditure(as % of GDP) of Low income in 2009 and the Expenditure(as % of GDP) of Nigeria in 2010?
Provide a succinct answer. 2.52. What is the difference between the Expenditure(as % of GDP) of Low income in 2009 and the Expenditure(as % of GDP) of Turkey in 2010?
Ensure brevity in your answer.  0.39. What is the difference between the Expenditure(as % of GDP) of Myanmar in 2009 and the Expenditure(as % of GDP) of Nigeria in 2010?
Provide a succinct answer. -1.38. What is the difference between the Expenditure(as % of GDP) of Myanmar in 2009 and the Expenditure(as % of GDP) of Turkey in 2010?
Provide a succinct answer. -3.5. What is the difference between the Expenditure(as % of GDP) of Nigeria in 2009 and the Expenditure(as % of GDP) of Turkey in 2010?
Give a very brief answer. -1.38. What is the average Expenditure(as % of GDP) in Low income per year?
Make the answer very short. 5.8. What is the average Expenditure(as % of GDP) of Myanmar per year?
Make the answer very short. 2.09. What is the average Expenditure(as % of GDP) in Nigeria per year?
Offer a terse response. 4.04. What is the average Expenditure(as % of GDP) in Turkey per year?
Provide a succinct answer. 5.72. In the year 2003, what is the difference between the Expenditure(as % of GDP) in Low income and Expenditure(as % of GDP) in Myanmar?
Offer a very short reply. 3.15. In the year 2003, what is the difference between the Expenditure(as % of GDP) of Low income and Expenditure(as % of GDP) of Nigeria?
Your answer should be very brief. 1.37. In the year 2003, what is the difference between the Expenditure(as % of GDP) of Low income and Expenditure(as % of GDP) of Turkey?
Provide a short and direct response. 0.08. In the year 2003, what is the difference between the Expenditure(as % of GDP) in Myanmar and Expenditure(as % of GDP) in Nigeria?
Make the answer very short. -1.78. In the year 2003, what is the difference between the Expenditure(as % of GDP) in Myanmar and Expenditure(as % of GDP) in Turkey?
Your response must be concise. -3.07. In the year 2003, what is the difference between the Expenditure(as % of GDP) in Nigeria and Expenditure(as % of GDP) in Turkey?
Provide a short and direct response. -1.29. In the year 2004, what is the difference between the Expenditure(as % of GDP) of Low income and Expenditure(as % of GDP) of Myanmar?
Offer a very short reply. 3.3. In the year 2004, what is the difference between the Expenditure(as % of GDP) in Low income and Expenditure(as % of GDP) in Nigeria?
Your answer should be compact. 1.24. In the year 2004, what is the difference between the Expenditure(as % of GDP) in Low income and Expenditure(as % of GDP) in Turkey?
Ensure brevity in your answer.  0.2. In the year 2004, what is the difference between the Expenditure(as % of GDP) in Myanmar and Expenditure(as % of GDP) in Nigeria?
Your response must be concise. -2.06. In the year 2004, what is the difference between the Expenditure(as % of GDP) in Myanmar and Expenditure(as % of GDP) in Turkey?
Make the answer very short. -3.1. In the year 2004, what is the difference between the Expenditure(as % of GDP) in Nigeria and Expenditure(as % of GDP) in Turkey?
Provide a short and direct response. -1.04. In the year 2005, what is the difference between the Expenditure(as % of GDP) in Low income and Expenditure(as % of GDP) in Myanmar?
Give a very brief answer. 3.52. In the year 2005, what is the difference between the Expenditure(as % of GDP) of Low income and Expenditure(as % of GDP) of Nigeria?
Give a very brief answer. 1.53. In the year 2005, what is the difference between the Expenditure(as % of GDP) in Low income and Expenditure(as % of GDP) in Turkey?
Ensure brevity in your answer.  0.19. In the year 2005, what is the difference between the Expenditure(as % of GDP) in Myanmar and Expenditure(as % of GDP) in Nigeria?
Provide a short and direct response. -1.99. In the year 2005, what is the difference between the Expenditure(as % of GDP) of Myanmar and Expenditure(as % of GDP) of Turkey?
Your response must be concise. -3.34. In the year 2005, what is the difference between the Expenditure(as % of GDP) in Nigeria and Expenditure(as % of GDP) in Turkey?
Keep it short and to the point. -1.34. In the year 2006, what is the difference between the Expenditure(as % of GDP) of Low income and Expenditure(as % of GDP) of Myanmar?
Offer a terse response. 3.83. In the year 2006, what is the difference between the Expenditure(as % of GDP) of Low income and Expenditure(as % of GDP) of Nigeria?
Make the answer very short. 2.23. In the year 2006, what is the difference between the Expenditure(as % of GDP) of Low income and Expenditure(as % of GDP) of Turkey?
Keep it short and to the point. 0.07. In the year 2006, what is the difference between the Expenditure(as % of GDP) of Myanmar and Expenditure(as % of GDP) of Nigeria?
Your answer should be very brief. -1.61. In the year 2006, what is the difference between the Expenditure(as % of GDP) of Myanmar and Expenditure(as % of GDP) of Turkey?
Give a very brief answer. -3.76. In the year 2006, what is the difference between the Expenditure(as % of GDP) of Nigeria and Expenditure(as % of GDP) of Turkey?
Offer a very short reply. -2.15. In the year 2007, what is the difference between the Expenditure(as % of GDP) of Low income and Expenditure(as % of GDP) of Myanmar?
Offer a terse response. 3.85. In the year 2007, what is the difference between the Expenditure(as % of GDP) in Low income and Expenditure(as % of GDP) in Nigeria?
Your answer should be compact. 1.32. In the year 2007, what is the difference between the Expenditure(as % of GDP) in Low income and Expenditure(as % of GDP) in Turkey?
Your response must be concise. -0.24. In the year 2007, what is the difference between the Expenditure(as % of GDP) of Myanmar and Expenditure(as % of GDP) of Nigeria?
Your answer should be very brief. -2.53. In the year 2007, what is the difference between the Expenditure(as % of GDP) in Myanmar and Expenditure(as % of GDP) in Turkey?
Ensure brevity in your answer.  -4.09. In the year 2007, what is the difference between the Expenditure(as % of GDP) of Nigeria and Expenditure(as % of GDP) of Turkey?
Your response must be concise. -1.56. In the year 2008, what is the difference between the Expenditure(as % of GDP) of Low income and Expenditure(as % of GDP) of Myanmar?
Keep it short and to the point. 3.57. In the year 2008, what is the difference between the Expenditure(as % of GDP) in Low income and Expenditure(as % of GDP) in Nigeria?
Make the answer very short. 1.6. In the year 2008, what is the difference between the Expenditure(as % of GDP) of Low income and Expenditure(as % of GDP) of Turkey?
Offer a terse response. -0.48. In the year 2008, what is the difference between the Expenditure(as % of GDP) of Myanmar and Expenditure(as % of GDP) of Nigeria?
Ensure brevity in your answer.  -1.97. In the year 2008, what is the difference between the Expenditure(as % of GDP) of Myanmar and Expenditure(as % of GDP) of Turkey?
Your answer should be compact. -4.04. In the year 2008, what is the difference between the Expenditure(as % of GDP) in Nigeria and Expenditure(as % of GDP) in Turkey?
Your response must be concise. -2.08. In the year 2009, what is the difference between the Expenditure(as % of GDP) in Low income and Expenditure(as % of GDP) in Myanmar?
Keep it short and to the point. 3.9. In the year 2009, what is the difference between the Expenditure(as % of GDP) in Low income and Expenditure(as % of GDP) in Nigeria?
Ensure brevity in your answer.  1.77. In the year 2009, what is the difference between the Expenditure(as % of GDP) in Low income and Expenditure(as % of GDP) in Turkey?
Ensure brevity in your answer.  -0.07. In the year 2009, what is the difference between the Expenditure(as % of GDP) in Myanmar and Expenditure(as % of GDP) in Nigeria?
Give a very brief answer. -2.12. In the year 2009, what is the difference between the Expenditure(as % of GDP) of Myanmar and Expenditure(as % of GDP) of Turkey?
Your answer should be compact. -3.97. In the year 2009, what is the difference between the Expenditure(as % of GDP) in Nigeria and Expenditure(as % of GDP) in Turkey?
Provide a succinct answer. -1.84. In the year 2010, what is the difference between the Expenditure(as % of GDP) in Low income and Expenditure(as % of GDP) in Myanmar?
Give a very brief answer. 4.54. In the year 2010, what is the difference between the Expenditure(as % of GDP) of Low income and Expenditure(as % of GDP) of Nigeria?
Your answer should be compact. 2.98. In the year 2010, what is the difference between the Expenditure(as % of GDP) in Low income and Expenditure(as % of GDP) in Turkey?
Offer a very short reply. 0.85. In the year 2010, what is the difference between the Expenditure(as % of GDP) of Myanmar and Expenditure(as % of GDP) of Nigeria?
Provide a succinct answer. -1.57. In the year 2010, what is the difference between the Expenditure(as % of GDP) in Myanmar and Expenditure(as % of GDP) in Turkey?
Ensure brevity in your answer.  -3.69. In the year 2010, what is the difference between the Expenditure(as % of GDP) of Nigeria and Expenditure(as % of GDP) of Turkey?
Provide a short and direct response. -2.13. What is the ratio of the Expenditure(as % of GDP) of Low income in 2003 to that in 2004?
Your answer should be very brief. 0.97. What is the ratio of the Expenditure(as % of GDP) of Myanmar in 2003 to that in 2004?
Make the answer very short. 1. What is the ratio of the Expenditure(as % of GDP) of Nigeria in 2003 to that in 2004?
Give a very brief answer. 0.94. What is the ratio of the Expenditure(as % of GDP) in Turkey in 2003 to that in 2004?
Keep it short and to the point. 0.99. What is the ratio of the Expenditure(as % of GDP) in Low income in 2003 to that in 2005?
Make the answer very short. 0.96. What is the ratio of the Expenditure(as % of GDP) of Myanmar in 2003 to that in 2005?
Your response must be concise. 1.07. What is the ratio of the Expenditure(as % of GDP) of Nigeria in 2003 to that in 2005?
Your response must be concise. 0.99. What is the ratio of the Expenditure(as % of GDP) in Turkey in 2003 to that in 2005?
Your response must be concise. 0.98. What is the ratio of the Expenditure(as % of GDP) in Low income in 2003 to that in 2006?
Your answer should be very brief. 0.92. What is the ratio of the Expenditure(as % of GDP) of Myanmar in 2003 to that in 2006?
Make the answer very short. 1.11. What is the ratio of the Expenditure(as % of GDP) of Nigeria in 2003 to that in 2006?
Your answer should be compact. 1.11. What is the ratio of the Expenditure(as % of GDP) in Turkey in 2003 to that in 2006?
Offer a very short reply. 0.92. What is the ratio of the Expenditure(as % of GDP) of Low income in 2003 to that in 2007?
Make the answer very short. 0.94. What is the ratio of the Expenditure(as % of GDP) of Myanmar in 2003 to that in 2007?
Your answer should be very brief. 1.17. What is the ratio of the Expenditure(as % of GDP) of Nigeria in 2003 to that in 2007?
Provide a short and direct response. 0.9. What is the ratio of the Expenditure(as % of GDP) in Turkey in 2003 to that in 2007?
Your answer should be very brief. 0.88. What is the ratio of the Expenditure(as % of GDP) in Low income in 2003 to that in 2008?
Keep it short and to the point. 0.97. What is the ratio of the Expenditure(as % of GDP) of Myanmar in 2003 to that in 2008?
Your response must be concise. 1.12. What is the ratio of the Expenditure(as % of GDP) in Nigeria in 2003 to that in 2008?
Your answer should be compact. 1.01. What is the ratio of the Expenditure(as % of GDP) of Turkey in 2003 to that in 2008?
Your response must be concise. 0.88. What is the ratio of the Expenditure(as % of GDP) in Low income in 2003 to that in 2009?
Ensure brevity in your answer.  0.9. What is the ratio of the Expenditure(as % of GDP) of Myanmar in 2003 to that in 2009?
Offer a terse response. 1.08. What is the ratio of the Expenditure(as % of GDP) of Nigeria in 2003 to that in 2009?
Provide a short and direct response. 0.96. What is the ratio of the Expenditure(as % of GDP) of Turkey in 2003 to that in 2009?
Give a very brief answer. 0.88. What is the ratio of the Expenditure(as % of GDP) in Low income in 2003 to that in 2010?
Provide a short and direct response. 0.84. What is the ratio of the Expenditure(as % of GDP) of Myanmar in 2003 to that in 2010?
Provide a short and direct response. 1.18. What is the ratio of the Expenditure(as % of GDP) of Nigeria in 2003 to that in 2010?
Offer a very short reply. 1.16. What is the ratio of the Expenditure(as % of GDP) of Turkey in 2003 to that in 2010?
Your response must be concise. 0.95. What is the ratio of the Expenditure(as % of GDP) in Low income in 2004 to that in 2005?
Make the answer very short. 0.99. What is the ratio of the Expenditure(as % of GDP) of Myanmar in 2004 to that in 2005?
Ensure brevity in your answer.  1.08. What is the ratio of the Expenditure(as % of GDP) of Nigeria in 2004 to that in 2005?
Your answer should be very brief. 1.05. What is the ratio of the Expenditure(as % of GDP) in Turkey in 2004 to that in 2005?
Offer a very short reply. 0.99. What is the ratio of the Expenditure(as % of GDP) in Low income in 2004 to that in 2006?
Provide a succinct answer. 0.95. What is the ratio of the Expenditure(as % of GDP) in Myanmar in 2004 to that in 2006?
Ensure brevity in your answer.  1.11. What is the ratio of the Expenditure(as % of GDP) in Nigeria in 2004 to that in 2006?
Your response must be concise. 1.18. What is the ratio of the Expenditure(as % of GDP) of Turkey in 2004 to that in 2006?
Keep it short and to the point. 0.92. What is the ratio of the Expenditure(as % of GDP) of Low income in 2004 to that in 2007?
Give a very brief answer. 0.96. What is the ratio of the Expenditure(as % of GDP) of Myanmar in 2004 to that in 2007?
Ensure brevity in your answer.  1.17. What is the ratio of the Expenditure(as % of GDP) in Nigeria in 2004 to that in 2007?
Make the answer very short. 0.97. What is the ratio of the Expenditure(as % of GDP) in Turkey in 2004 to that in 2007?
Offer a terse response. 0.89. What is the ratio of the Expenditure(as % of GDP) of Low income in 2004 to that in 2008?
Your response must be concise. 1. What is the ratio of the Expenditure(as % of GDP) of Myanmar in 2004 to that in 2008?
Give a very brief answer. 1.12. What is the ratio of the Expenditure(as % of GDP) of Nigeria in 2004 to that in 2008?
Your answer should be compact. 1.08. What is the ratio of the Expenditure(as % of GDP) in Turkey in 2004 to that in 2008?
Your answer should be very brief. 0.88. What is the ratio of the Expenditure(as % of GDP) in Low income in 2004 to that in 2009?
Your answer should be very brief. 0.93. What is the ratio of the Expenditure(as % of GDP) in Myanmar in 2004 to that in 2009?
Make the answer very short. 1.08. What is the ratio of the Expenditure(as % of GDP) in Nigeria in 2004 to that in 2009?
Ensure brevity in your answer.  1.02. What is the ratio of the Expenditure(as % of GDP) in Turkey in 2004 to that in 2009?
Give a very brief answer. 0.88. What is the ratio of the Expenditure(as % of GDP) in Low income in 2004 to that in 2010?
Make the answer very short. 0.86. What is the ratio of the Expenditure(as % of GDP) in Myanmar in 2004 to that in 2010?
Give a very brief answer. 1.18. What is the ratio of the Expenditure(as % of GDP) in Nigeria in 2004 to that in 2010?
Your answer should be very brief. 1.24. What is the ratio of the Expenditure(as % of GDP) in Turkey in 2004 to that in 2010?
Ensure brevity in your answer.  0.96. What is the ratio of the Expenditure(as % of GDP) in Low income in 2005 to that in 2006?
Your answer should be very brief. 0.96. What is the ratio of the Expenditure(as % of GDP) of Myanmar in 2005 to that in 2006?
Give a very brief answer. 1.03. What is the ratio of the Expenditure(as % of GDP) of Nigeria in 2005 to that in 2006?
Your response must be concise. 1.12. What is the ratio of the Expenditure(as % of GDP) of Turkey in 2005 to that in 2006?
Offer a very short reply. 0.94. What is the ratio of the Expenditure(as % of GDP) in Low income in 2005 to that in 2007?
Your response must be concise. 0.97. What is the ratio of the Expenditure(as % of GDP) in Myanmar in 2005 to that in 2007?
Ensure brevity in your answer.  1.09. What is the ratio of the Expenditure(as % of GDP) in Nigeria in 2005 to that in 2007?
Make the answer very short. 0.92. What is the ratio of the Expenditure(as % of GDP) of Turkey in 2005 to that in 2007?
Provide a succinct answer. 0.9. What is the ratio of the Expenditure(as % of GDP) of Low income in 2005 to that in 2008?
Provide a succinct answer. 1.01. What is the ratio of the Expenditure(as % of GDP) in Myanmar in 2005 to that in 2008?
Your answer should be very brief. 1.04. What is the ratio of the Expenditure(as % of GDP) of Nigeria in 2005 to that in 2008?
Offer a very short reply. 1.03. What is the ratio of the Expenditure(as % of GDP) in Turkey in 2005 to that in 2008?
Make the answer very short. 0.9. What is the ratio of the Expenditure(as % of GDP) of Low income in 2005 to that in 2009?
Keep it short and to the point. 0.94. What is the ratio of the Expenditure(as % of GDP) in Myanmar in 2005 to that in 2009?
Your response must be concise. 1. What is the ratio of the Expenditure(as % of GDP) in Nigeria in 2005 to that in 2009?
Offer a very short reply. 0.97. What is the ratio of the Expenditure(as % of GDP) in Turkey in 2005 to that in 2009?
Offer a very short reply. 0.9. What is the ratio of the Expenditure(as % of GDP) of Low income in 2005 to that in 2010?
Offer a very short reply. 0.87. What is the ratio of the Expenditure(as % of GDP) in Myanmar in 2005 to that in 2010?
Keep it short and to the point. 1.1. What is the ratio of the Expenditure(as % of GDP) in Nigeria in 2005 to that in 2010?
Your response must be concise. 1.18. What is the ratio of the Expenditure(as % of GDP) in Turkey in 2005 to that in 2010?
Provide a succinct answer. 0.97. What is the ratio of the Expenditure(as % of GDP) of Low income in 2006 to that in 2007?
Ensure brevity in your answer.  1.02. What is the ratio of the Expenditure(as % of GDP) in Myanmar in 2006 to that in 2007?
Offer a very short reply. 1.05. What is the ratio of the Expenditure(as % of GDP) in Nigeria in 2006 to that in 2007?
Your response must be concise. 0.82. What is the ratio of the Expenditure(as % of GDP) of Turkey in 2006 to that in 2007?
Offer a very short reply. 0.96. What is the ratio of the Expenditure(as % of GDP) of Low income in 2006 to that in 2008?
Your response must be concise. 1.05. What is the ratio of the Expenditure(as % of GDP) of Myanmar in 2006 to that in 2008?
Your response must be concise. 1.01. What is the ratio of the Expenditure(as % of GDP) in Nigeria in 2006 to that in 2008?
Keep it short and to the point. 0.91. What is the ratio of the Expenditure(as % of GDP) of Turkey in 2006 to that in 2008?
Provide a succinct answer. 0.96. What is the ratio of the Expenditure(as % of GDP) of Low income in 2006 to that in 2009?
Provide a short and direct response. 0.98. What is the ratio of the Expenditure(as % of GDP) in Myanmar in 2006 to that in 2009?
Provide a succinct answer. 0.97. What is the ratio of the Expenditure(as % of GDP) in Nigeria in 2006 to that in 2009?
Your response must be concise. 0.86. What is the ratio of the Expenditure(as % of GDP) in Turkey in 2006 to that in 2009?
Provide a succinct answer. 0.96. What is the ratio of the Expenditure(as % of GDP) of Low income in 2006 to that in 2010?
Make the answer very short. 0.91. What is the ratio of the Expenditure(as % of GDP) in Myanmar in 2006 to that in 2010?
Make the answer very short. 1.07. What is the ratio of the Expenditure(as % of GDP) of Nigeria in 2006 to that in 2010?
Your response must be concise. 1.05. What is the ratio of the Expenditure(as % of GDP) in Turkey in 2006 to that in 2010?
Your answer should be compact. 1.04. What is the ratio of the Expenditure(as % of GDP) of Low income in 2007 to that in 2008?
Provide a succinct answer. 1.04. What is the ratio of the Expenditure(as % of GDP) of Myanmar in 2007 to that in 2008?
Your response must be concise. 0.96. What is the ratio of the Expenditure(as % of GDP) of Nigeria in 2007 to that in 2008?
Provide a succinct answer. 1.12. What is the ratio of the Expenditure(as % of GDP) of Turkey in 2007 to that in 2008?
Provide a succinct answer. 0.99. What is the ratio of the Expenditure(as % of GDP) of Low income in 2007 to that in 2009?
Provide a succinct answer. 0.96. What is the ratio of the Expenditure(as % of GDP) in Myanmar in 2007 to that in 2009?
Offer a very short reply. 0.92. What is the ratio of the Expenditure(as % of GDP) of Nigeria in 2007 to that in 2009?
Give a very brief answer. 1.06. What is the ratio of the Expenditure(as % of GDP) in Turkey in 2007 to that in 2009?
Offer a very short reply. 0.99. What is the ratio of the Expenditure(as % of GDP) in Low income in 2007 to that in 2010?
Provide a succinct answer. 0.9. What is the ratio of the Expenditure(as % of GDP) of Myanmar in 2007 to that in 2010?
Your answer should be compact. 1.01. What is the ratio of the Expenditure(as % of GDP) in Nigeria in 2007 to that in 2010?
Your answer should be compact. 1.28. What is the ratio of the Expenditure(as % of GDP) of Turkey in 2007 to that in 2010?
Give a very brief answer. 1.08. What is the ratio of the Expenditure(as % of GDP) of Low income in 2008 to that in 2009?
Give a very brief answer. 0.93. What is the ratio of the Expenditure(as % of GDP) of Myanmar in 2008 to that in 2009?
Offer a terse response. 0.96. What is the ratio of the Expenditure(as % of GDP) of Nigeria in 2008 to that in 2009?
Keep it short and to the point. 0.94. What is the ratio of the Expenditure(as % of GDP) of Low income in 2008 to that in 2010?
Your response must be concise. 0.87. What is the ratio of the Expenditure(as % of GDP) of Myanmar in 2008 to that in 2010?
Give a very brief answer. 1.06. What is the ratio of the Expenditure(as % of GDP) of Nigeria in 2008 to that in 2010?
Offer a very short reply. 1.15. What is the ratio of the Expenditure(as % of GDP) in Turkey in 2008 to that in 2010?
Your response must be concise. 1.08. What is the ratio of the Expenditure(as % of GDP) in Low income in 2009 to that in 2010?
Your response must be concise. 0.93. What is the ratio of the Expenditure(as % of GDP) of Myanmar in 2009 to that in 2010?
Keep it short and to the point. 1.1. What is the ratio of the Expenditure(as % of GDP) in Nigeria in 2009 to that in 2010?
Make the answer very short. 1.21. What is the ratio of the Expenditure(as % of GDP) of Turkey in 2009 to that in 2010?
Give a very brief answer. 1.08. What is the difference between the highest and the second highest Expenditure(as % of GDP) of Low income?
Provide a succinct answer. 0.46. What is the difference between the highest and the second highest Expenditure(as % of GDP) of Myanmar?
Provide a succinct answer. 0. What is the difference between the highest and the second highest Expenditure(as % of GDP) in Nigeria?
Make the answer very short. 0.15. What is the difference between the highest and the second highest Expenditure(as % of GDP) of Turkey?
Provide a short and direct response. 0.01. What is the difference between the highest and the lowest Expenditure(as % of GDP) of Low income?
Keep it short and to the point. 1.04. What is the difference between the highest and the lowest Expenditure(as % of GDP) of Myanmar?
Your answer should be very brief. 0.35. What is the difference between the highest and the lowest Expenditure(as % of GDP) of Nigeria?
Offer a terse response. 0.99. What is the difference between the highest and the lowest Expenditure(as % of GDP) of Turkey?
Your answer should be compact. 0.74. 